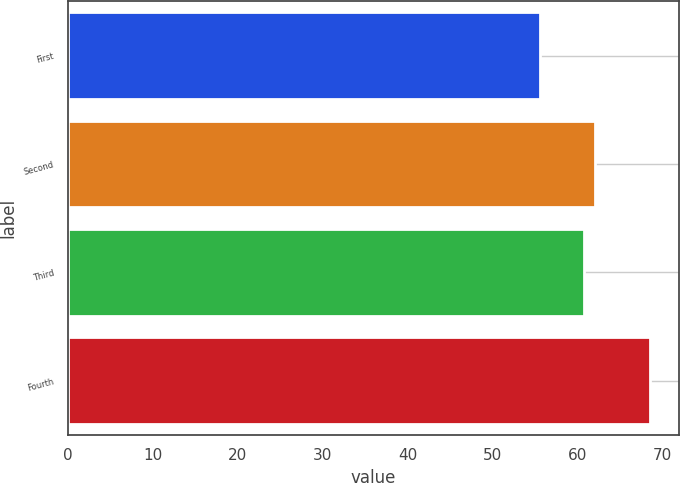Convert chart. <chart><loc_0><loc_0><loc_500><loc_500><bar_chart><fcel>First<fcel>Second<fcel>Third<fcel>Fourth<nl><fcel>55.6<fcel>62.04<fcel>60.75<fcel>68.5<nl></chart> 